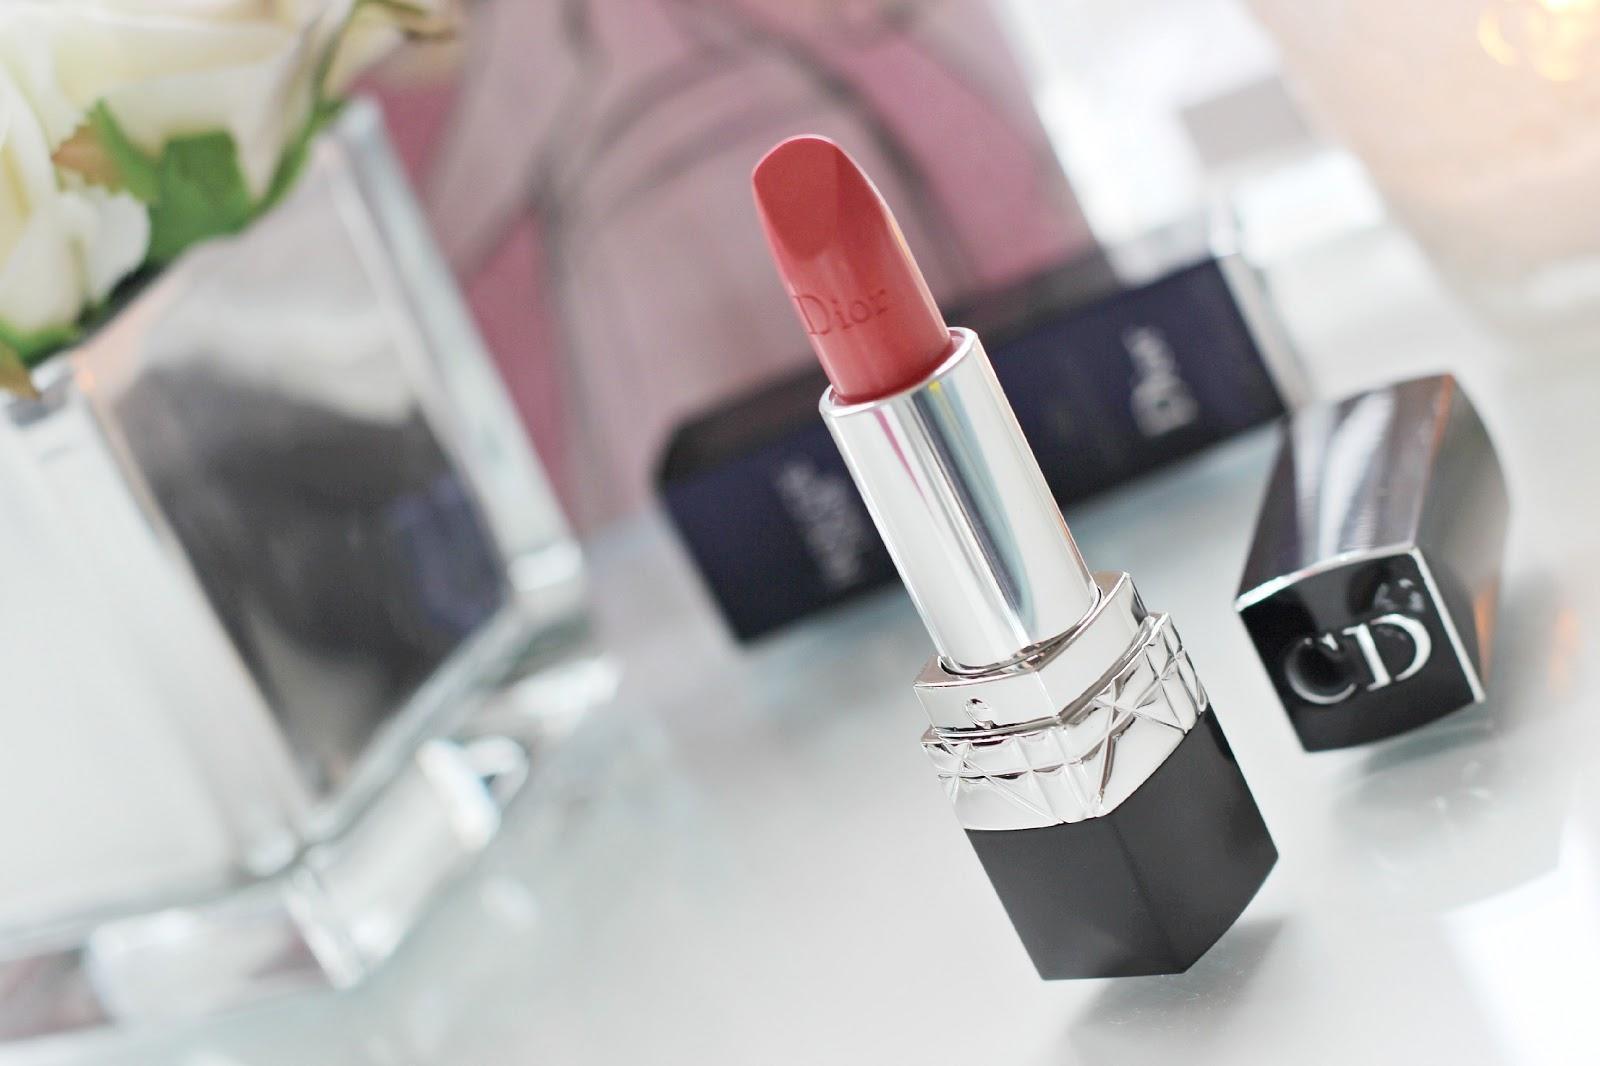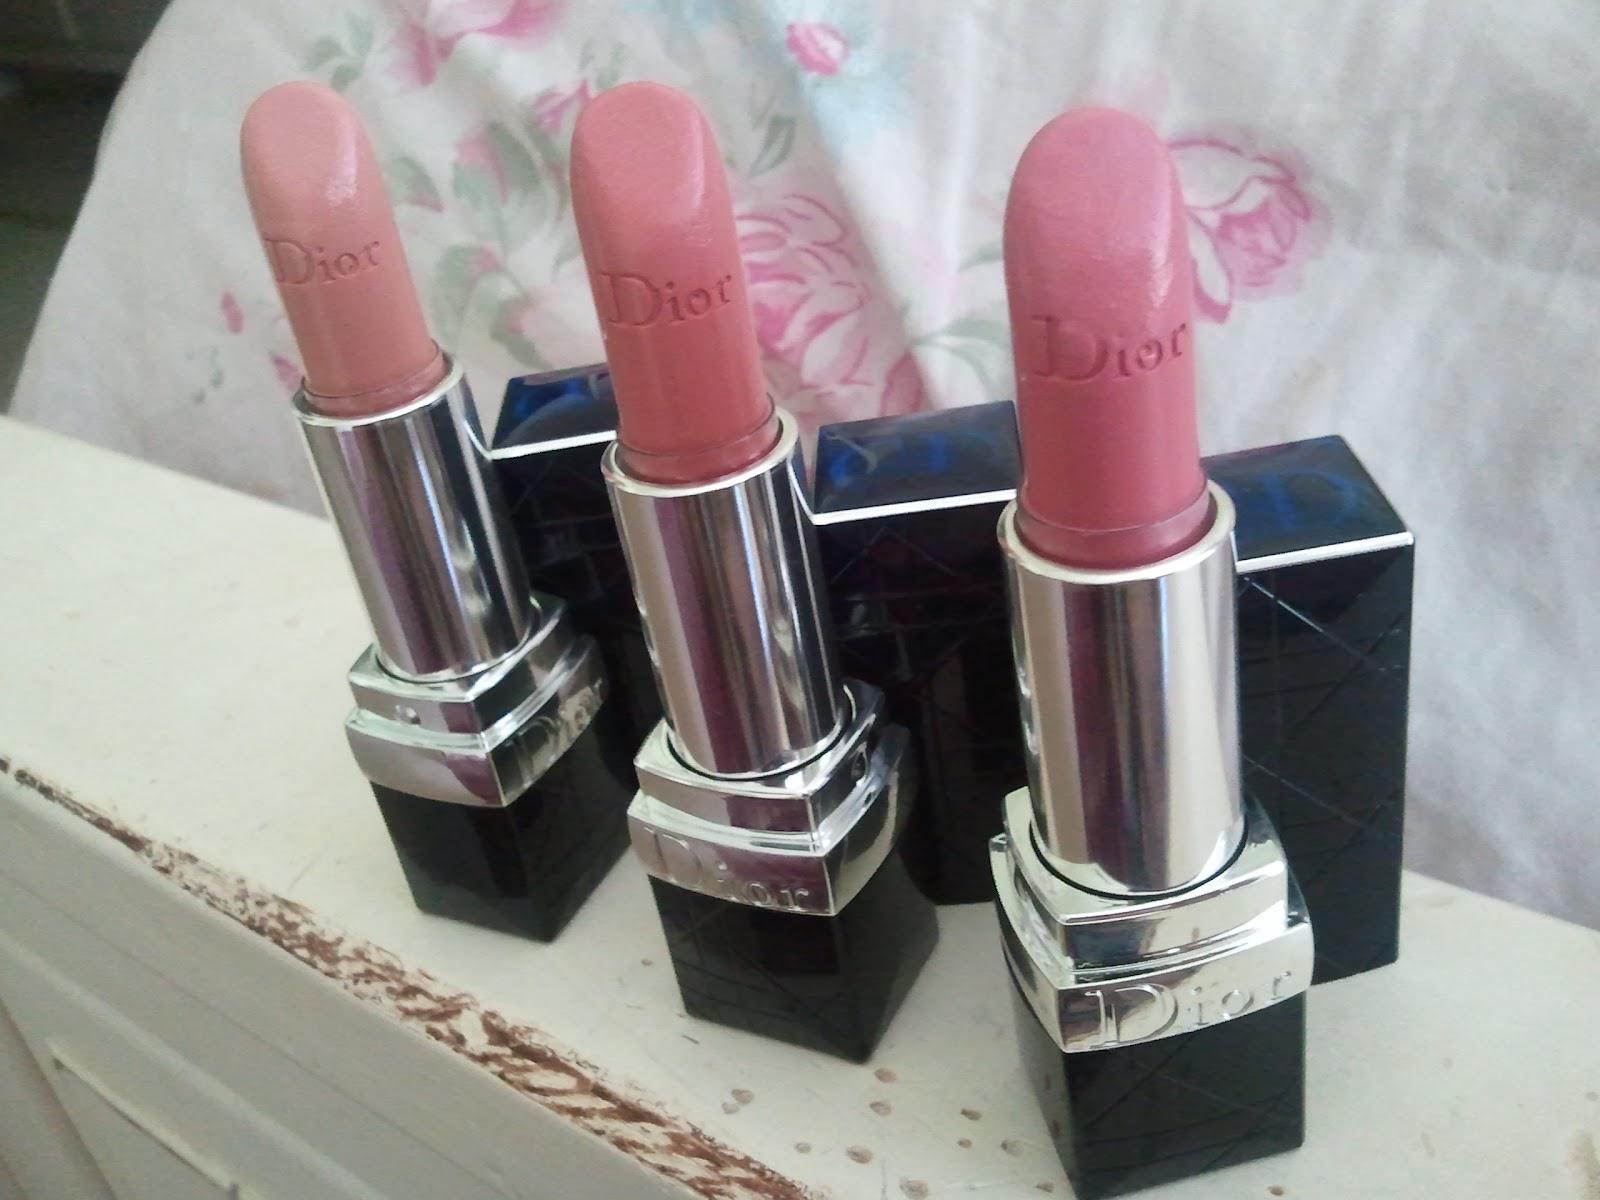The first image is the image on the left, the second image is the image on the right. Evaluate the accuracy of this statement regarding the images: "One of the images shows a single lipstick on display and the other shows a group of at least three lipsticks.". Is it true? Answer yes or no. Yes. 